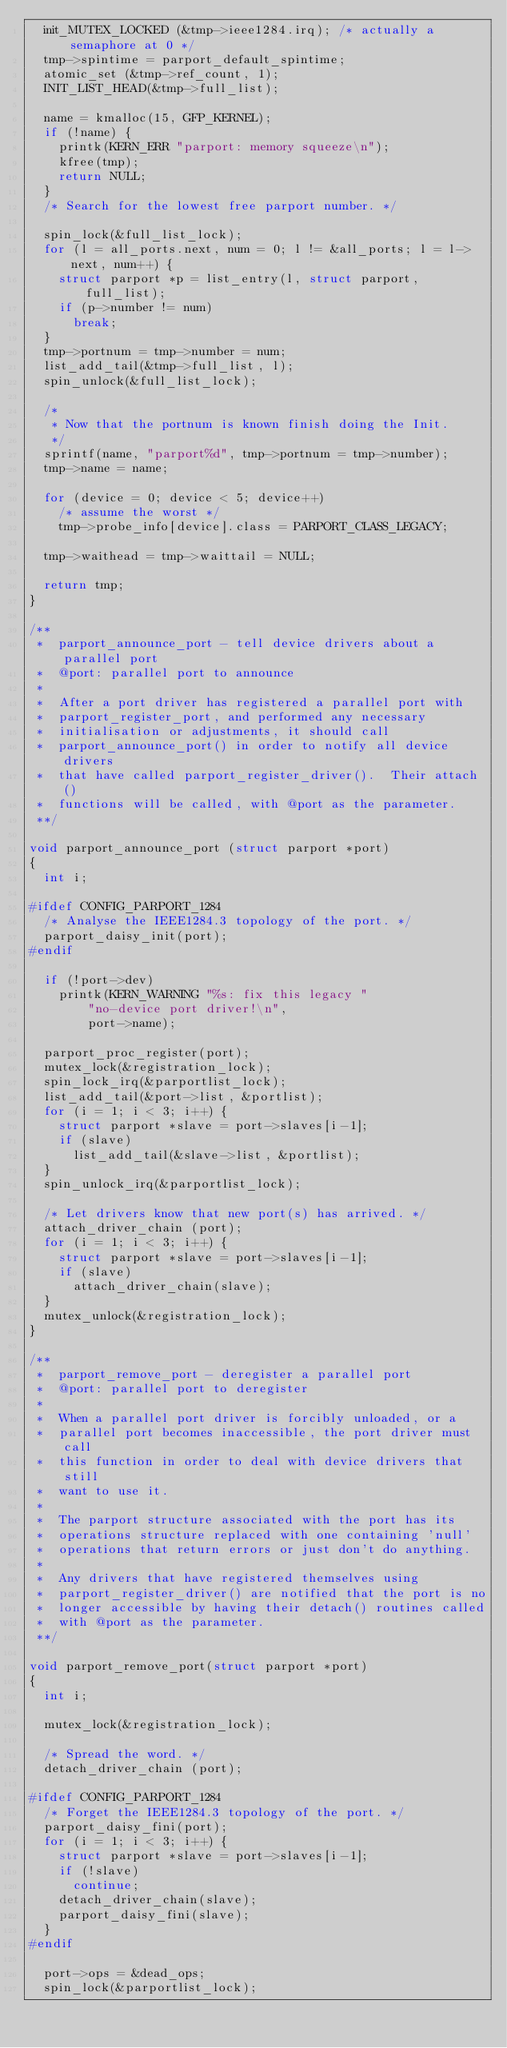<code> <loc_0><loc_0><loc_500><loc_500><_C_>	init_MUTEX_LOCKED (&tmp->ieee1284.irq); /* actually a semaphore at 0 */
	tmp->spintime = parport_default_spintime;
	atomic_set (&tmp->ref_count, 1);
	INIT_LIST_HEAD(&tmp->full_list);

	name = kmalloc(15, GFP_KERNEL);
	if (!name) {
		printk(KERN_ERR "parport: memory squeeze\n");
		kfree(tmp);
		return NULL;
	}
	/* Search for the lowest free parport number. */

	spin_lock(&full_list_lock);
	for (l = all_ports.next, num = 0; l != &all_ports; l = l->next, num++) {
		struct parport *p = list_entry(l, struct parport, full_list);
		if (p->number != num)
			break;
	}
	tmp->portnum = tmp->number = num;
	list_add_tail(&tmp->full_list, l);
	spin_unlock(&full_list_lock);

	/*
	 * Now that the portnum is known finish doing the Init.
	 */
	sprintf(name, "parport%d", tmp->portnum = tmp->number);
	tmp->name = name;

	for (device = 0; device < 5; device++)
		/* assume the worst */
		tmp->probe_info[device].class = PARPORT_CLASS_LEGACY;

	tmp->waithead = tmp->waittail = NULL;

	return tmp;
}

/**
 *	parport_announce_port - tell device drivers about a parallel port
 *	@port: parallel port to announce
 *
 *	After a port driver has registered a parallel port with
 *	parport_register_port, and performed any necessary
 *	initialisation or adjustments, it should call
 *	parport_announce_port() in order to notify all device drivers
 *	that have called parport_register_driver().  Their attach()
 *	functions will be called, with @port as the parameter.
 **/

void parport_announce_port (struct parport *port)
{
	int i;

#ifdef CONFIG_PARPORT_1284
	/* Analyse the IEEE1284.3 topology of the port. */
	parport_daisy_init(port);
#endif

	if (!port->dev)
		printk(KERN_WARNING "%s: fix this legacy "
				"no-device port driver!\n",
				port->name);

	parport_proc_register(port);
	mutex_lock(&registration_lock);
	spin_lock_irq(&parportlist_lock);
	list_add_tail(&port->list, &portlist);
	for (i = 1; i < 3; i++) {
		struct parport *slave = port->slaves[i-1];
		if (slave)
			list_add_tail(&slave->list, &portlist);
	}
	spin_unlock_irq(&parportlist_lock);

	/* Let drivers know that new port(s) has arrived. */
	attach_driver_chain (port);
	for (i = 1; i < 3; i++) {
		struct parport *slave = port->slaves[i-1];
		if (slave)
			attach_driver_chain(slave);
	}
	mutex_unlock(&registration_lock);
}

/**
 *	parport_remove_port - deregister a parallel port
 *	@port: parallel port to deregister
 *
 *	When a parallel port driver is forcibly unloaded, or a
 *	parallel port becomes inaccessible, the port driver must call
 *	this function in order to deal with device drivers that still
 *	want to use it.
 *
 *	The parport structure associated with the port has its
 *	operations structure replaced with one containing 'null'
 *	operations that return errors or just don't do anything.
 *
 *	Any drivers that have registered themselves using
 *	parport_register_driver() are notified that the port is no
 *	longer accessible by having their detach() routines called
 *	with @port as the parameter.
 **/

void parport_remove_port(struct parport *port)
{
	int i;

	mutex_lock(&registration_lock);

	/* Spread the word. */
	detach_driver_chain (port);

#ifdef CONFIG_PARPORT_1284
	/* Forget the IEEE1284.3 topology of the port. */
	parport_daisy_fini(port);
	for (i = 1; i < 3; i++) {
		struct parport *slave = port->slaves[i-1];
		if (!slave)
			continue;
		detach_driver_chain(slave);
		parport_daisy_fini(slave);
	}
#endif

	port->ops = &dead_ops;
	spin_lock(&parportlist_lock);</code> 